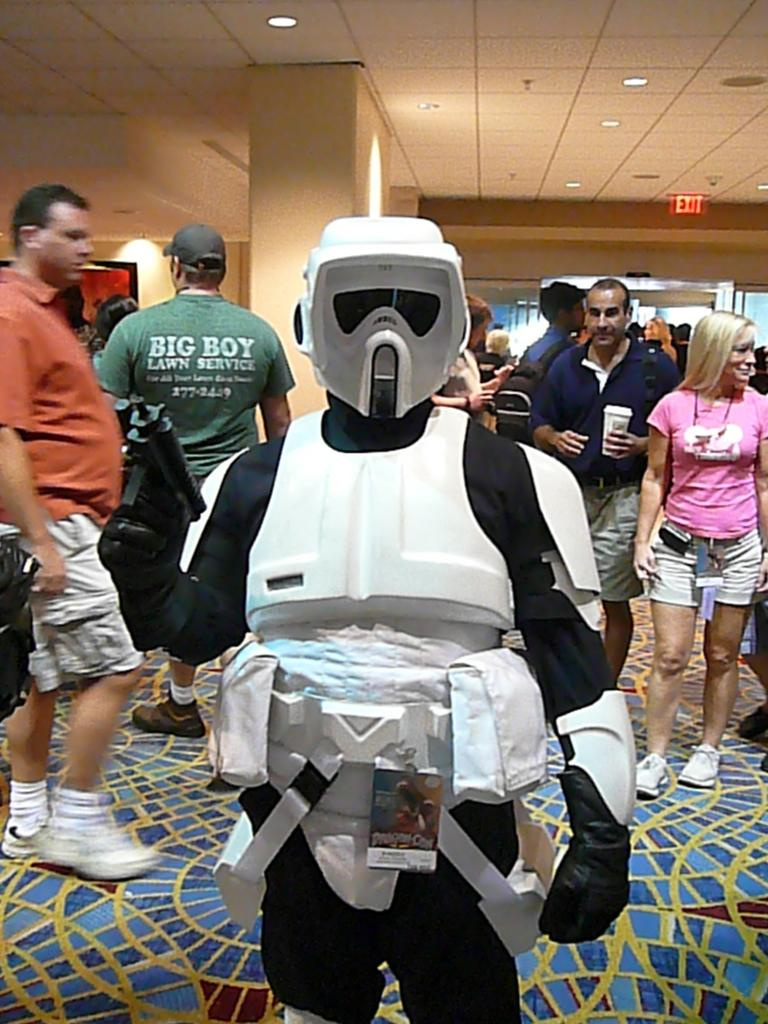What is the person in the image wearing? There is a person in a costume in the image. How many people are standing in the image? There is a group of people standing in the image. What can be seen illuminating the scene in the image? There are lights visible in the image. What might be used to indicate the direction of an exit in the image? There is an exit board in the image. What type of coal is being transported on the street in the image? There is no street or coal present in the image. How does the rail system function in the image? There is no rail system present in the image. 